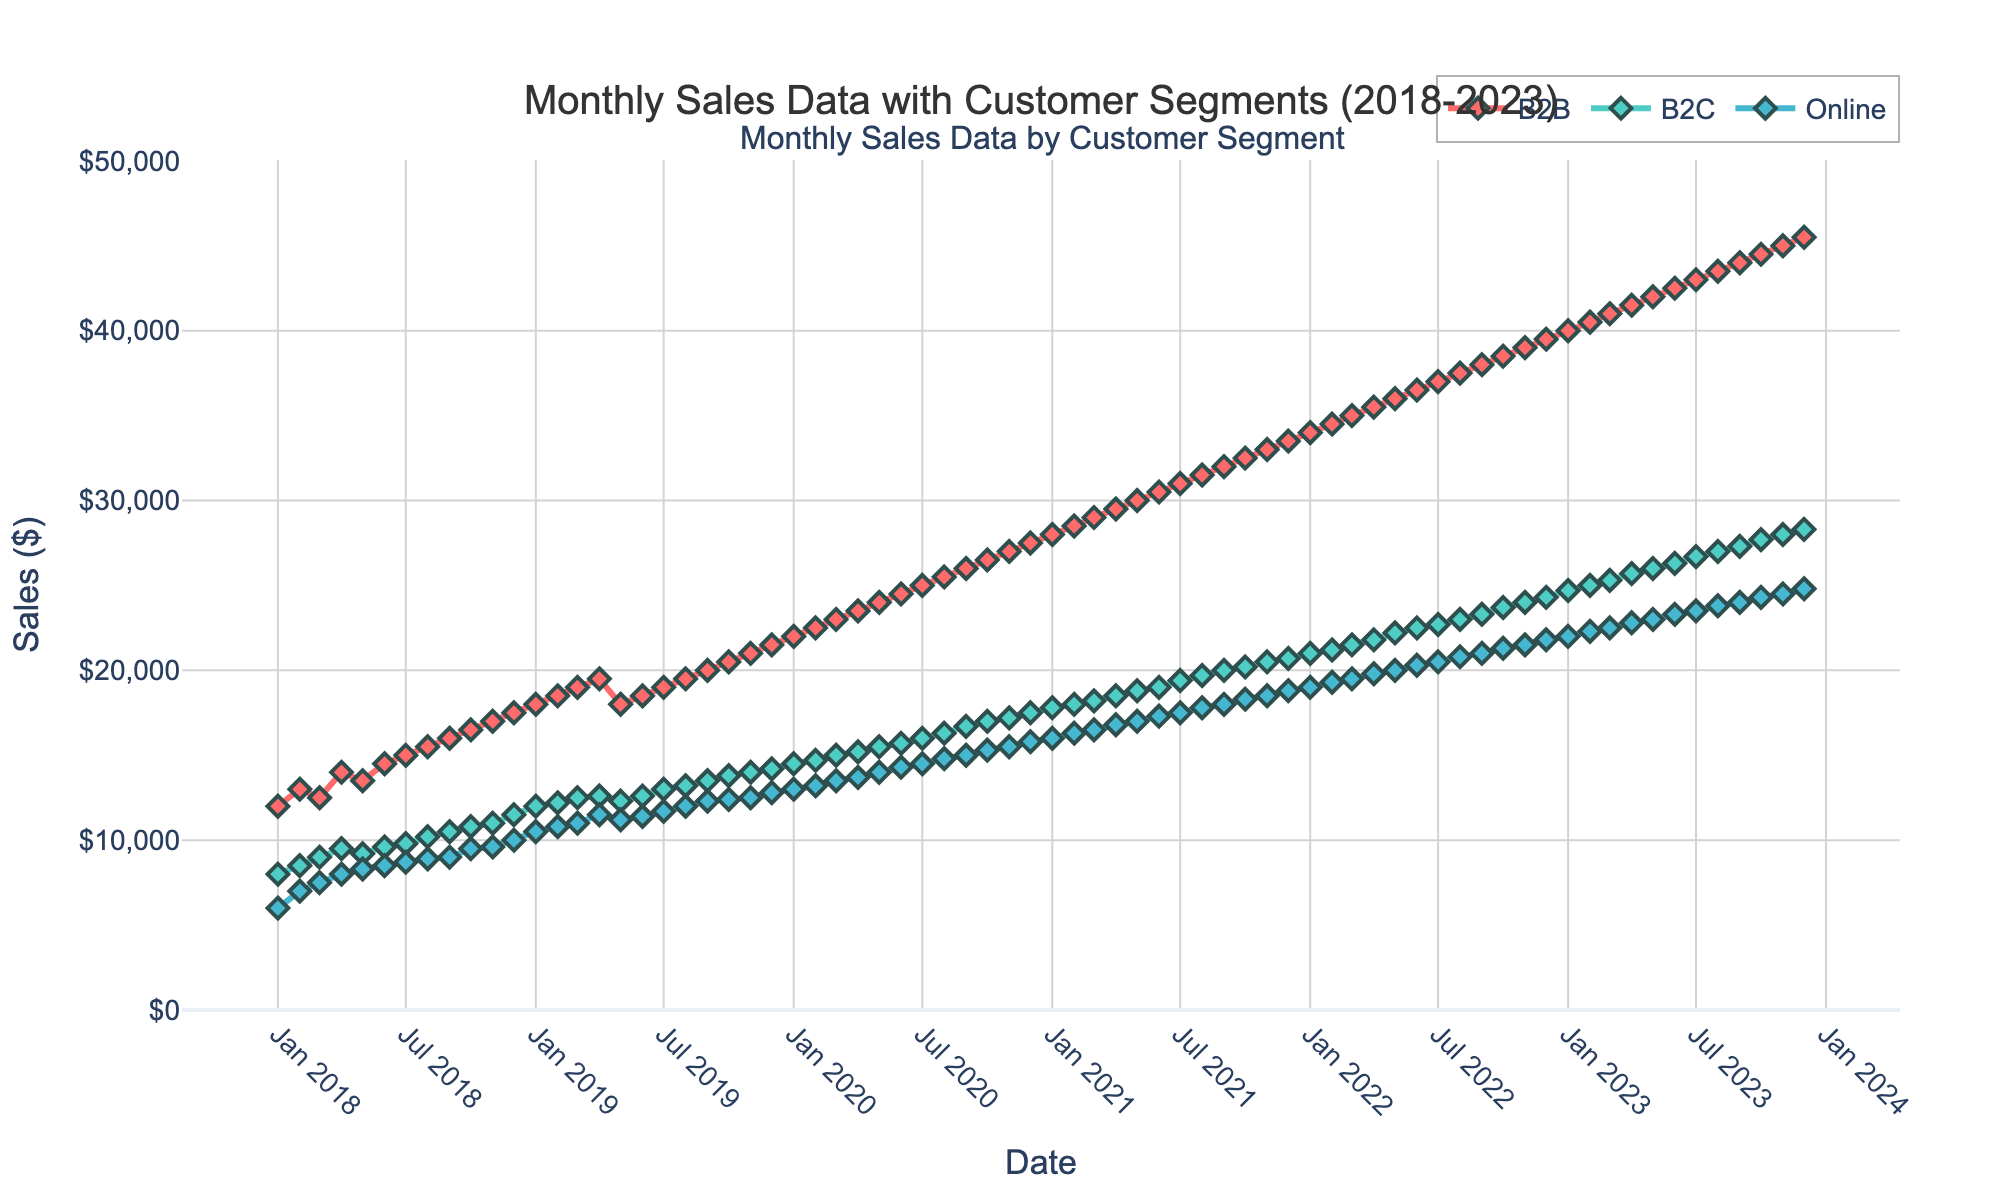What is the title of the plot? The title of the plot is displayed at the top and reads “Monthly Sales Data with Customer Segments (2018-2023).”
Answer: Monthly Sales Data with Customer Segments (2018-2023) What are the three customer segments represented in the plot? The plot uses a legend to represent three customer segments: B2B, B2C, and Online.
Answer: B2B, B2C, and Online What is the maximum sales value in the plot, and which customer segment does it belong to? By observing the plot, the highest sales value appears to be $45,500 in October 2023, which belongs to the B2B segment.
Answer: $45,500, B2B In which month and year did the B2C segment first reach monthly sales of $20,000? Looking through the B2C sales line, it first reaches $20,000 in September 2021.
Answer: September 2021 Which customer segment has the lowest overall sales and what is its lowest value in the plot? The Online segment has the lowest overall sales, with the lowest value being $6,000 in January 2018.
Answer: Online, $6,000 What is the average monthly sales value for the B2B segment over the entire period shown? To find this, sum all monthly B2B sales values, then divide by the number of months. Total B2B sales = 1,198,500, number of months = 72, thus average = 1,198,500 / 72
Answer: $16,652.78 Between January 2018 and December 2023, how much did the sales for the Online segment increase? The sales for the Online segment increased from $6,000 in January 2018 to $24,800 in December 2023, which is an increase of $24,800 - $6,000 = $18,800.
Answer: $18,800 Which segment experienced the highest growth rate, and how can you determine this growth rate? By calculating the difference between the end and start values, B2B grew from $12,000 to $45,500, the highest numerical increase. Growth rate = (45500 - 12000) / 12000 * 100 = 279.17%.
Answer: B2B, 279.17% What patterns or trends can be observed in the sales data for the B2C segment over the past five years? The B2C sales data shows a consistent upward trend, with no significant drops, indicating steady growth.
Answer: Steady growth During which period did the Online segment show the most significant increase? The most significant increase in the Online segment appears to be between January 2020 and January 2021, where it increased from $13,000 to $16,000.
Answer: January 2020 to January 2021 Compare the sales increase of B2B and B2C segments from January 2018 to January 2023. Which segment had a higher increase? B2B sales increased from $12,000 in January 2018 to $40,000 in January 2023 (+$28,000). B2C sales increased from $8,000 to $24,700 (+$16,700). B2B had a higher increase.
Answer: B2B segment, +$28,000 